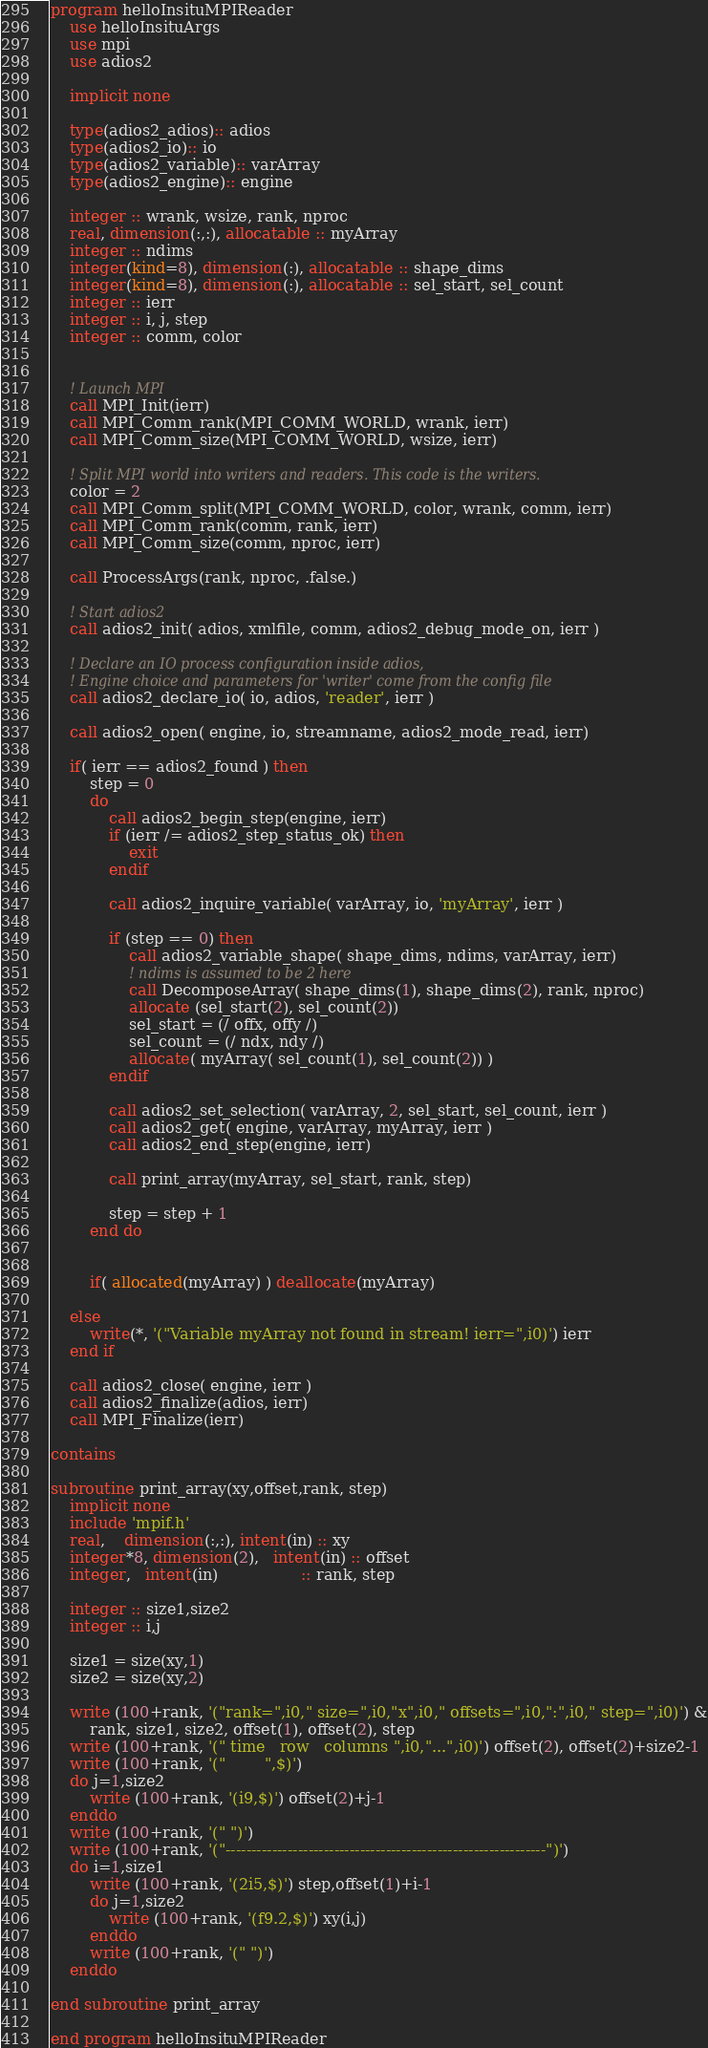<code> <loc_0><loc_0><loc_500><loc_500><_FORTRAN_>program helloInsituMPIReader
    use helloInsituArgs
    use mpi
    use adios2

    implicit none

    type(adios2_adios):: adios
    type(adios2_io):: io
    type(adios2_variable):: varArray
    type(adios2_engine):: engine

    integer :: wrank, wsize, rank, nproc
    real, dimension(:,:), allocatable :: myArray
    integer :: ndims
    integer(kind=8), dimension(:), allocatable :: shape_dims
    integer(kind=8), dimension(:), allocatable :: sel_start, sel_count
    integer :: ierr
    integer :: i, j, step
    integer :: comm, color


    ! Launch MPI
    call MPI_Init(ierr)
    call MPI_Comm_rank(MPI_COMM_WORLD, wrank, ierr)
    call MPI_Comm_size(MPI_COMM_WORLD, wsize, ierr)

    ! Split MPI world into writers and readers. This code is the writers.
    color = 2
    call MPI_Comm_split(MPI_COMM_WORLD, color, wrank, comm, ierr)
    call MPI_Comm_rank(comm, rank, ierr)
    call MPI_Comm_size(comm, nproc, ierr)

    call ProcessArgs(rank, nproc, .false.)

    ! Start adios2
    call adios2_init( adios, xmlfile, comm, adios2_debug_mode_on, ierr )

    ! Declare an IO process configuration inside adios,
    ! Engine choice and parameters for 'writer' come from the config file
    call adios2_declare_io( io, adios, 'reader', ierr )

    call adios2_open( engine, io, streamname, adios2_mode_read, ierr)

    if( ierr == adios2_found ) then
        step = 0
        do
            call adios2_begin_step(engine, ierr)
            if (ierr /= adios2_step_status_ok) then
                exit
            endif

            call adios2_inquire_variable( varArray, io, 'myArray', ierr )

            if (step == 0) then
                call adios2_variable_shape( shape_dims, ndims, varArray, ierr)
                ! ndims is assumed to be 2 here
                call DecomposeArray( shape_dims(1), shape_dims(2), rank, nproc)
                allocate (sel_start(2), sel_count(2))
                sel_start = (/ offx, offy /)
                sel_count = (/ ndx, ndy /)
                allocate( myArray( sel_count(1), sel_count(2)) )
            endif

            call adios2_set_selection( varArray, 2, sel_start, sel_count, ierr )
            call adios2_get( engine, varArray, myArray, ierr )
            call adios2_end_step(engine, ierr)

            call print_array(myArray, sel_start, rank, step)

            step = step + 1
        end do


        if( allocated(myArray) ) deallocate(myArray)

    else
        write(*, '("Variable myArray not found in stream! ierr=",i0)') ierr
    end if

    call adios2_close( engine, ierr )
    call adios2_finalize(adios, ierr)
    call MPI_Finalize(ierr)

contains

subroutine print_array(xy,offset,rank, step)
    implicit none
    include 'mpif.h'
    real,    dimension(:,:), intent(in) :: xy
    integer*8, dimension(2),   intent(in) :: offset
    integer,   intent(in)                 :: rank, step

    integer :: size1,size2
    integer :: i,j

    size1 = size(xy,1)
    size2 = size(xy,2)

    write (100+rank, '("rank=",i0," size=",i0,"x",i0," offsets=",i0,":",i0," step=",i0)') &
        rank, size1, size2, offset(1), offset(2), step
    write (100+rank, '(" time   row   columns ",i0,"...",i0)') offset(2), offset(2)+size2-1
    write (100+rank, '("        ",$)')
    do j=1,size2
        write (100+rank, '(i9,$)') offset(2)+j-1
    enddo
    write (100+rank, '(" ")')
    write (100+rank, '("--------------------------------------------------------------")')
    do i=1,size1
        write (100+rank, '(2i5,$)') step,offset(1)+i-1
        do j=1,size2
            write (100+rank, '(f9.2,$)') xy(i,j)
        enddo
        write (100+rank, '(" ")')
    enddo

end subroutine print_array

end program helloInsituMPIReader

</code> 